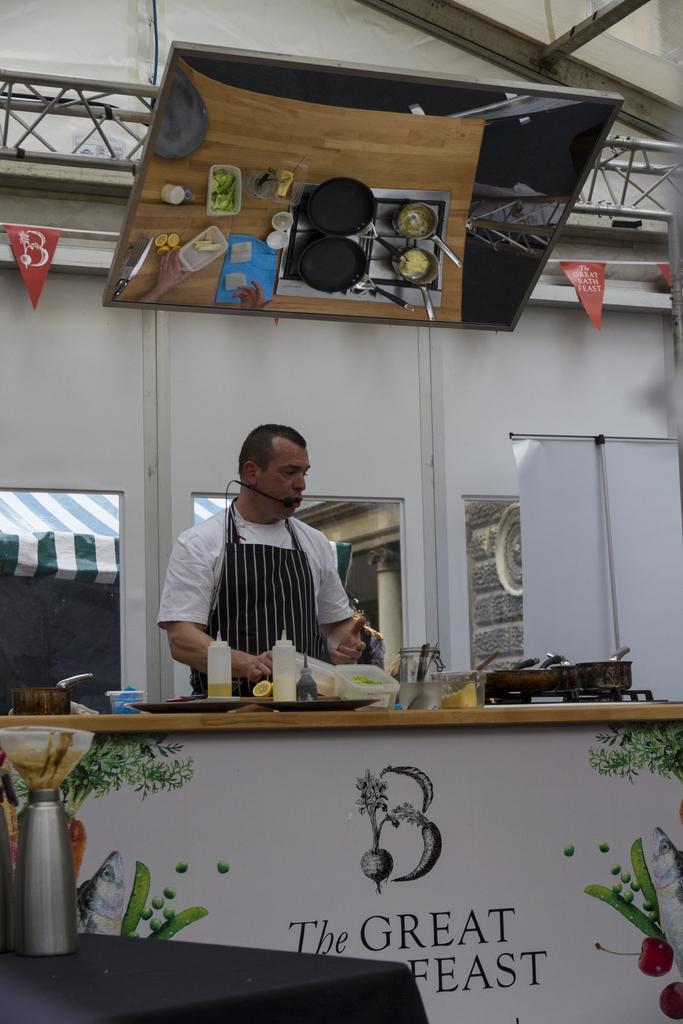How would you summarize this image in a sentence or two? In the center of the image we can see a man standing. He is wearing an apron, before him there is a table and we can see a stove, vessels, bottles, boxes and a pan placed on the table. On the left we can see bottles placed on the stand. In the background there is a wall, windows and a chimney. 